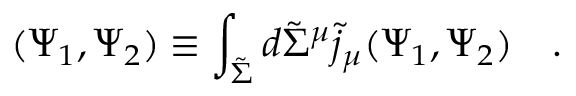<formula> <loc_0><loc_0><loc_500><loc_500>( \Psi _ { 1 } , \Psi _ { 2 } ) \equiv \int _ { \tilde { \Sigma } } d \tilde { \Sigma } ^ { \mu } \tilde { j } _ { \mu } ( \Psi _ { 1 } , \Psi _ { 2 } ) .</formula> 